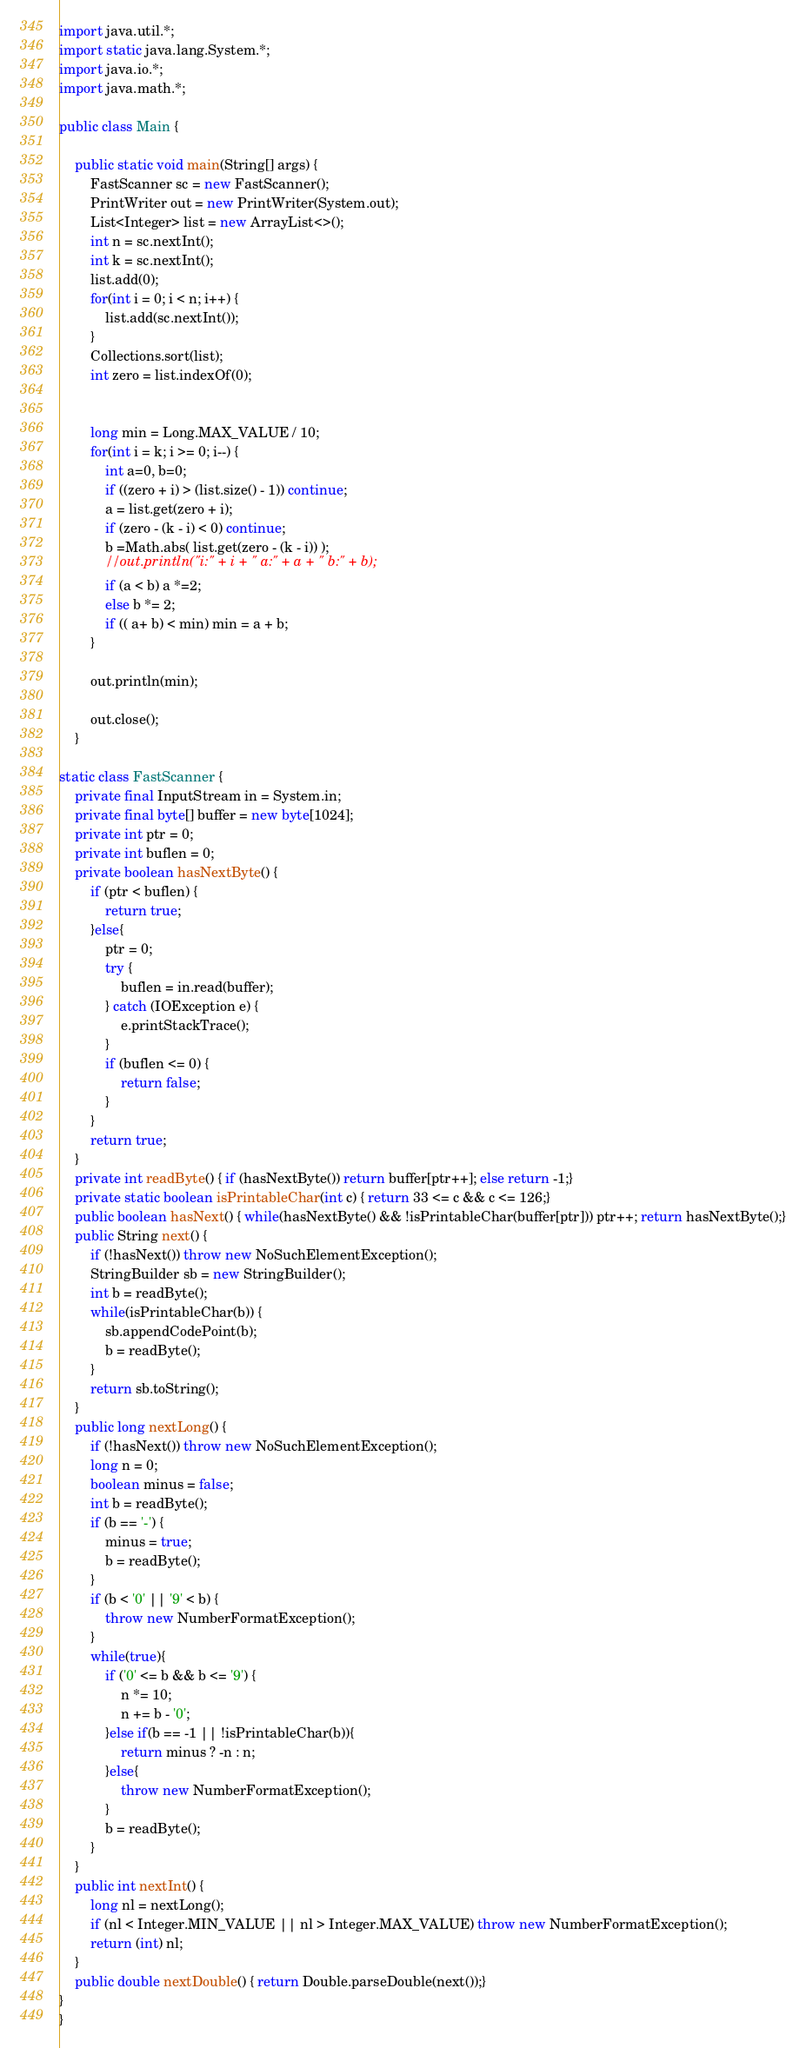Convert code to text. <code><loc_0><loc_0><loc_500><loc_500><_Java_>import java.util.*;
import static java.lang.System.*;
import java.io.*;
import java.math.*;

public class Main {

	public static void main(String[] args) {
		FastScanner sc = new FastScanner();
		PrintWriter out = new PrintWriter(System.out);
		List<Integer> list = new ArrayList<>();
		int n = sc.nextInt();
		int k = sc.nextInt();
		list.add(0);
		for(int i = 0; i < n; i++) {
			list.add(sc.nextInt());
		}
		Collections.sort(list);
		int zero = list.indexOf(0);

		
		long min = Long.MAX_VALUE / 10;
		for(int i = k; i >= 0; i--) {
			int a=0, b=0;
			if ((zero + i) > (list.size() - 1)) continue;
			a = list.get(zero + i);
			if (zero - (k - i) < 0) continue;
			b =Math.abs( list.get(zero - (k - i)) );
			//out.println("i:" + i + " a:" + a + " b:" + b);
			if (a < b) a *=2;
			else b *= 2;
			if (( a+ b) < min) min = a + b;
		}
		
		out.println(min);

		out.close();
	}

static class FastScanner {
    private final InputStream in = System.in;
    private final byte[] buffer = new byte[1024];
    private int ptr = 0;
    private int buflen = 0;
    private boolean hasNextByte() {
        if (ptr < buflen) {
            return true;
        }else{
            ptr = 0;
            try {
                buflen = in.read(buffer);
            } catch (IOException e) {
                e.printStackTrace();
            }
            if (buflen <= 0) {
                return false;
            }
        }
        return true;
    }
    private int readByte() { if (hasNextByte()) return buffer[ptr++]; else return -1;}
    private static boolean isPrintableChar(int c) { return 33 <= c && c <= 126;}
    public boolean hasNext() { while(hasNextByte() && !isPrintableChar(buffer[ptr])) ptr++; return hasNextByte();}
    public String next() {
        if (!hasNext()) throw new NoSuchElementException();
        StringBuilder sb = new StringBuilder();
        int b = readByte();
        while(isPrintableChar(b)) {
            sb.appendCodePoint(b);
            b = readByte();
        }
        return sb.toString();
    }
    public long nextLong() {
        if (!hasNext()) throw new NoSuchElementException();
        long n = 0;
        boolean minus = false;
        int b = readByte();
        if (b == '-') {
            minus = true;
            b = readByte();
        }
        if (b < '0' || '9' < b) {
            throw new NumberFormatException();
        }
        while(true){
            if ('0' <= b && b <= '9') {
                n *= 10;
                n += b - '0';
            }else if(b == -1 || !isPrintableChar(b)){
                return minus ? -n : n;
            }else{
                throw new NumberFormatException();
            }
            b = readByte();
        }
    }
    public int nextInt() {
        long nl = nextLong();
        if (nl < Integer.MIN_VALUE || nl > Integer.MAX_VALUE) throw new NumberFormatException();
        return (int) nl;
    }
    public double nextDouble() { return Double.parseDouble(next());}
}
}</code> 